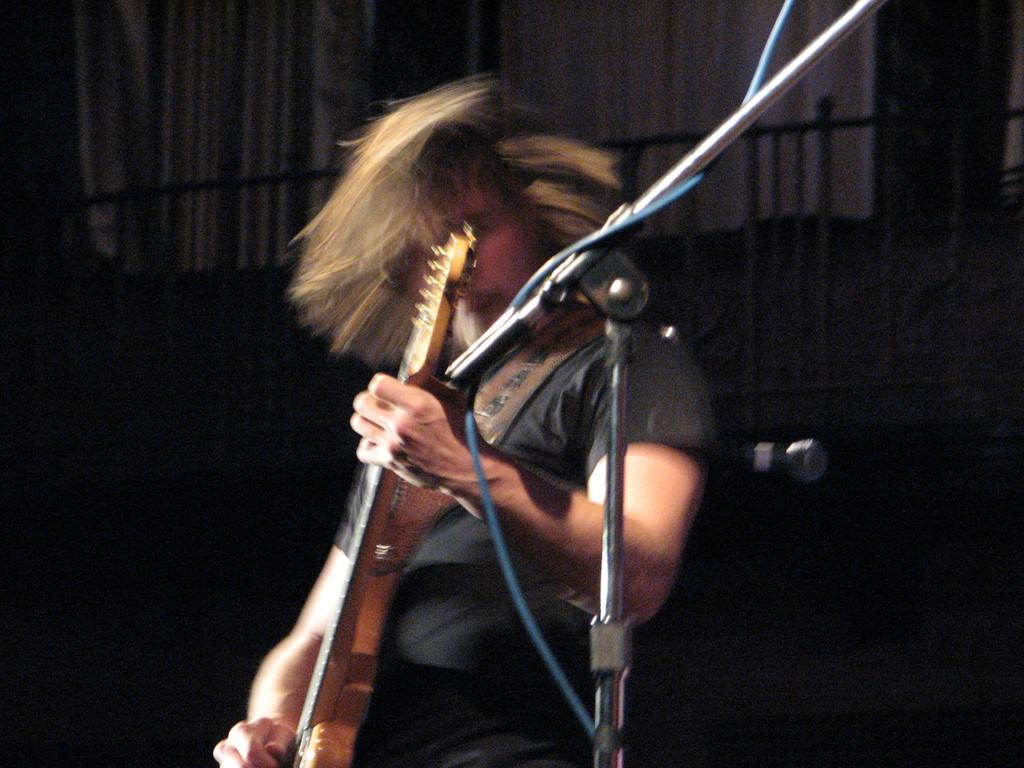What is located in the foreground of the image? There is a mic stand, a cable, and a man holding a guitar in the foreground of the image. What can be seen in the background of the image? The background of the image is dark and includes railing, a white curtain, and a mic. What is the man in the foreground of the image doing? The man is holding a guitar in the foreground of the image. What type of pump is visible in the image? There is no pump present in the image. What is the man wearing on his wrist in the image? The man is not wearing a watch or any other visible accessory on his wrist in the image. 